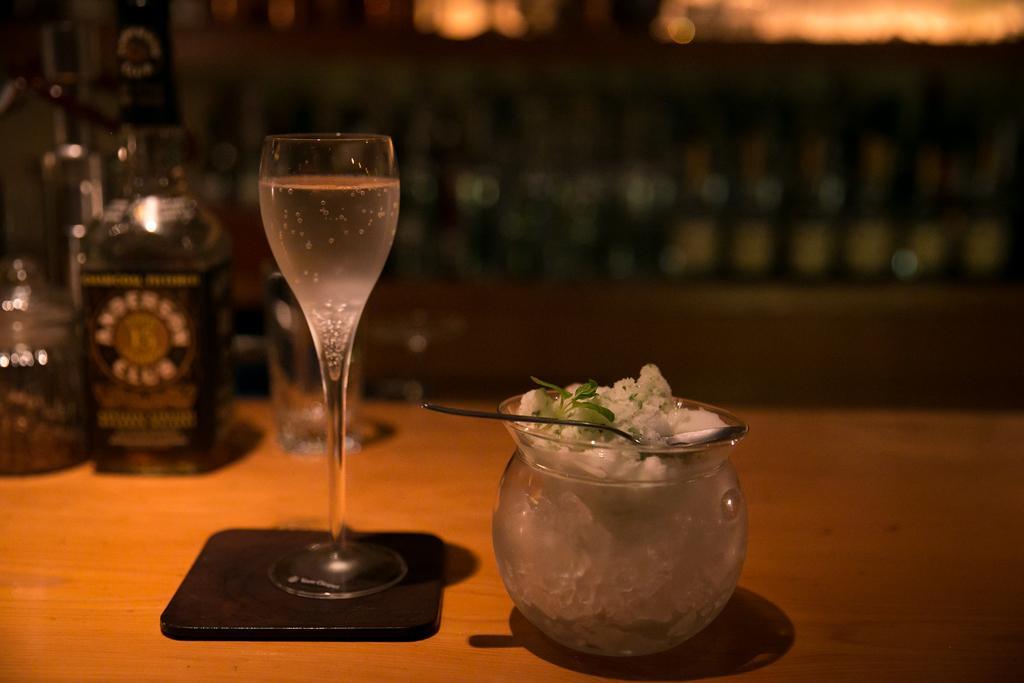How would you summarize this image in a sentence or two? In the picture we can see a table on it, we can see a jar with some flowers which are white in color and some leaf and besides it, we can see a glass of drink and on the small black color mat and behind it we can see some wine bottle and some glass beside it. 